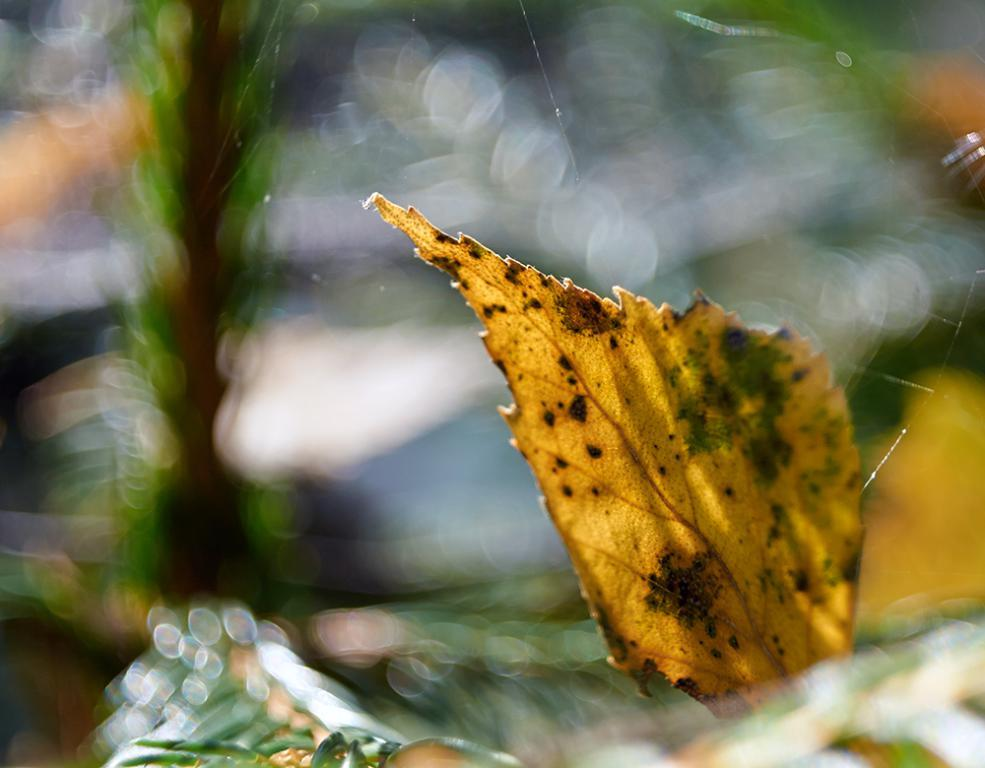What is the main subject of the image? The main subject of the image is a leaf in yellow color. Where is the leaf located in the image? The leaf is in the middle of the image. What can be seen in the background of the image? There is a plant or a tree in the background of the image. How is the background of the image depicted? The background is blurred. What type of rock can be seen in the image? There is no rock present in the image; it features a yellow leaf in the middle and a blurred background with a plant or a tree. Is there any religious symbolism in the image? There is no indication of any religious symbolism or spiritual elements in the image. 